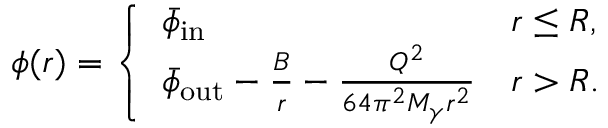Convert formula to latex. <formula><loc_0><loc_0><loc_500><loc_500>\phi ( r ) = \left \{ \begin{array} { l l } { \bar { \phi } _ { i n } } & { r \leq R , } \\ { \bar { \phi } _ { o u t } - \frac { B } { r } - \frac { Q ^ { 2 } } { 6 4 \pi ^ { 2 } M _ { \gamma } r ^ { 2 } } } & { r > R . } \end{array}</formula> 